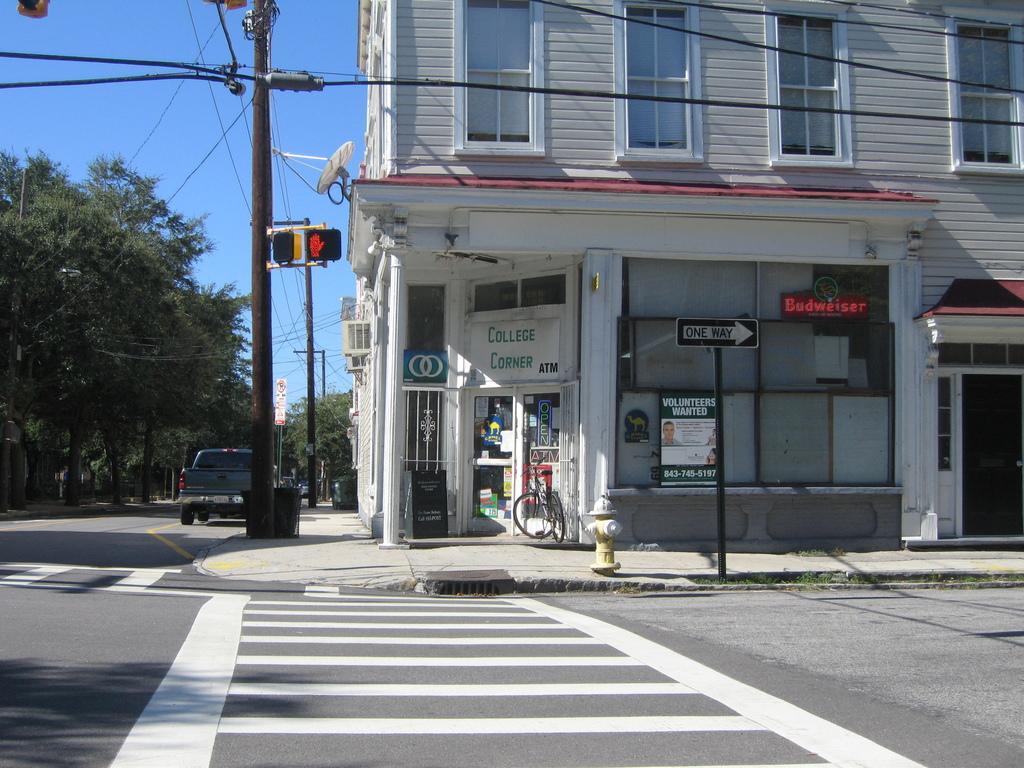Please provide a concise description of this image. In this image we can see buildings, windows, there are posters with text on them, there is a vehicle on the road, there is a bicycle, there are poles, wires, trees, also we can see the dish antenna and the sky. 